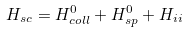<formula> <loc_0><loc_0><loc_500><loc_500>H _ { s c } = H _ { c o l l } ^ { 0 } + H _ { s p } ^ { 0 } + H _ { i i }</formula> 